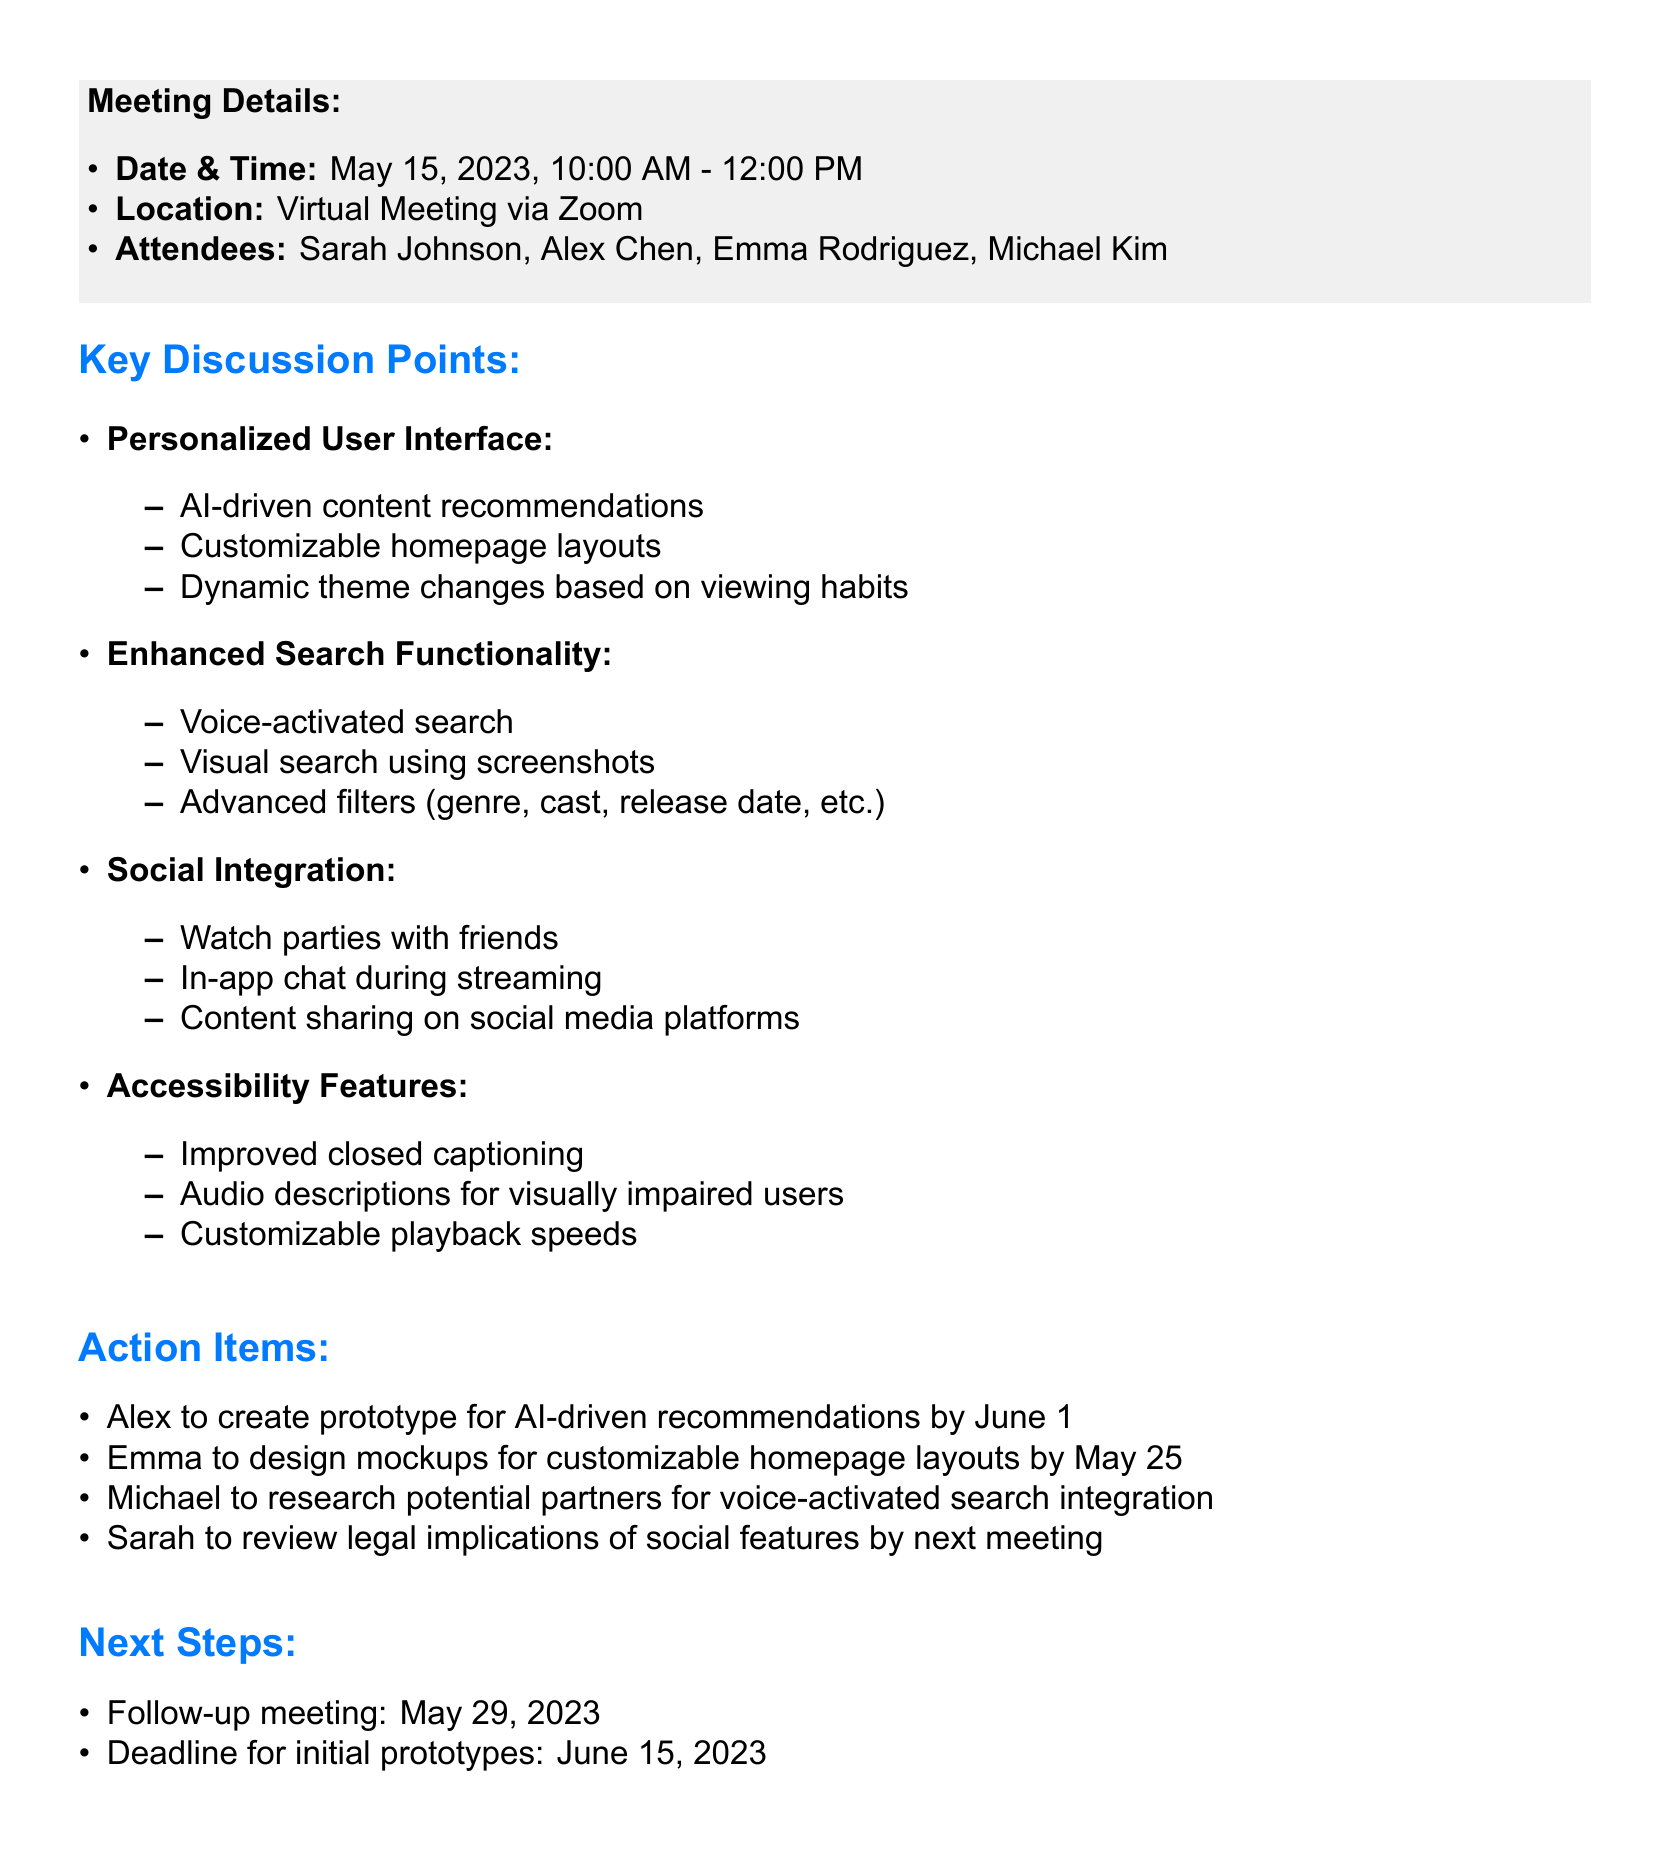What date was the meeting held? The meeting was held on May 15, 2023.
Answer: May 15, 2023 Who is responsible for designing mockups for customizable homepage layouts? Emma is tasked with designing mockups for customizable homepage layouts.
Answer: Emma What is one idea proposed for the enhanced search functionality? One proposed idea for enhanced search functionality is voice-activated search.
Answer: Voice-activated search When is the deadline for initial prototypes? The deadline for initial prototypes is June 15, 2023.
Answer: June 15, 2023 Which feature aims to improve accessibility? Improved closed captioning is one feature aimed at accessibility.
Answer: Improved closed captioning What is the main purpose of the follow-up meeting? The follow-up meeting is for reviewing progress and discussing further steps.
Answer: Reviewing progress How many attendees were present at the meeting? There were four attendees present at the meeting.
Answer: Four What social feature was discussed in the meeting? One discussed social feature is watch parties with friends.
Answer: Watch parties with friends Which action item is assigned to Michael? Michael is tasked with researching potential partners for voice-activated search integration.
Answer: Research potential partners 